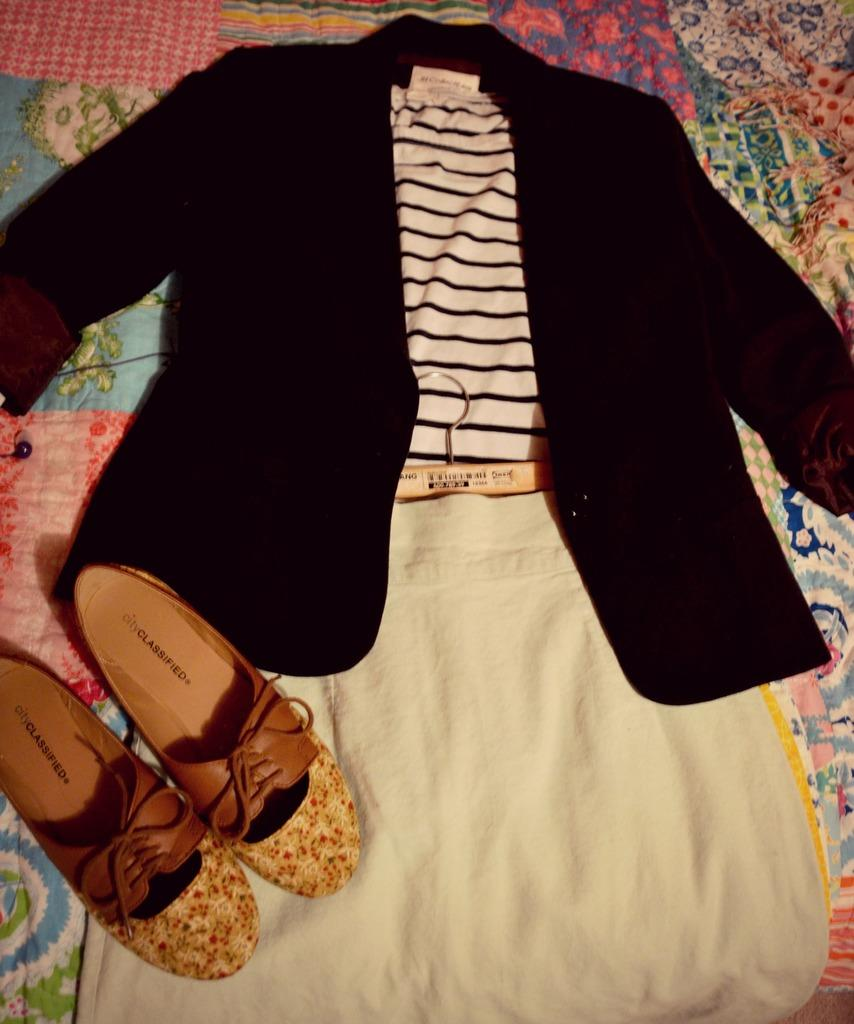What color is the jacket in the image? The jacket in the image is black. What color is the T-shirt in the image? The T-shirt in the image is white. What type of clothing item is the white color skirt in the image? The white color item in the image is a skirt. How are the clothing items arranged in the image? The clothing items are hung on a hanger. What other items can be seen in the image besides the clothing items? There are shoes and an earphone in the image. Where are the items placed in the image? The items are placed on a bed with bed-sheets. What type of fang can be seen in the image? There is no fang present in the image. What hope does the person in the image have for the future? The image does not provide any information about the person's hopes for the future. 